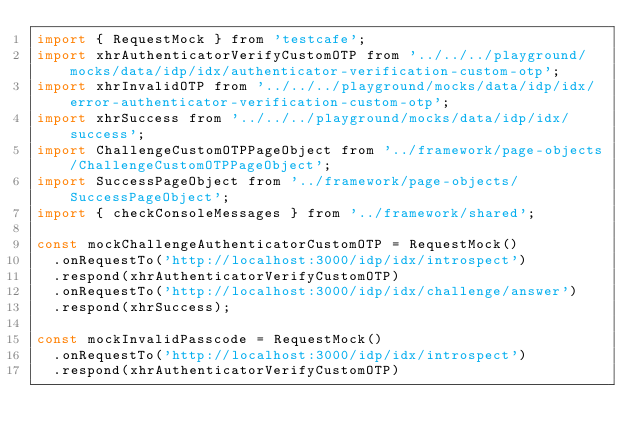<code> <loc_0><loc_0><loc_500><loc_500><_JavaScript_>import { RequestMock } from 'testcafe';
import xhrAuthenticatorVerifyCustomOTP from '../../../playground/mocks/data/idp/idx/authenticator-verification-custom-otp';
import xhrInvalidOTP from '../../../playground/mocks/data/idp/idx/error-authenticator-verification-custom-otp';
import xhrSuccess from '../../../playground/mocks/data/idp/idx/success';
import ChallengeCustomOTPPageObject from '../framework/page-objects/ChallengeCustomOTPPageObject';
import SuccessPageObject from '../framework/page-objects/SuccessPageObject';
import { checkConsoleMessages } from '../framework/shared';

const mockChallengeAuthenticatorCustomOTP = RequestMock()
  .onRequestTo('http://localhost:3000/idp/idx/introspect')
  .respond(xhrAuthenticatorVerifyCustomOTP)
  .onRequestTo('http://localhost:3000/idp/idx/challenge/answer')
  .respond(xhrSuccess);

const mockInvalidPasscode = RequestMock()
  .onRequestTo('http://localhost:3000/idp/idx/introspect')
  .respond(xhrAuthenticatorVerifyCustomOTP)</code> 